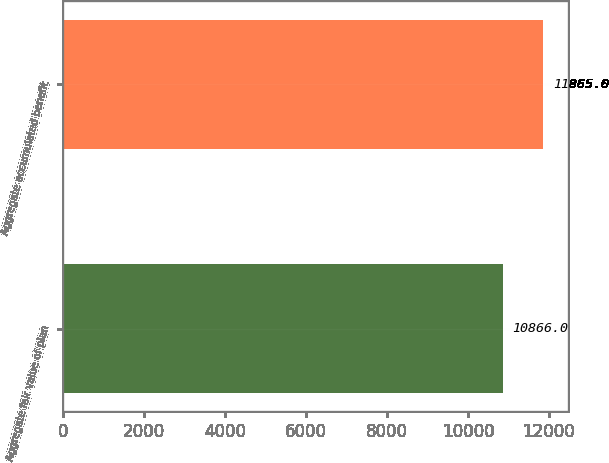<chart> <loc_0><loc_0><loc_500><loc_500><bar_chart><fcel>Aggregate fair value of plan<fcel>Aggregate accumulated benefit<nl><fcel>10866<fcel>11865<nl></chart> 